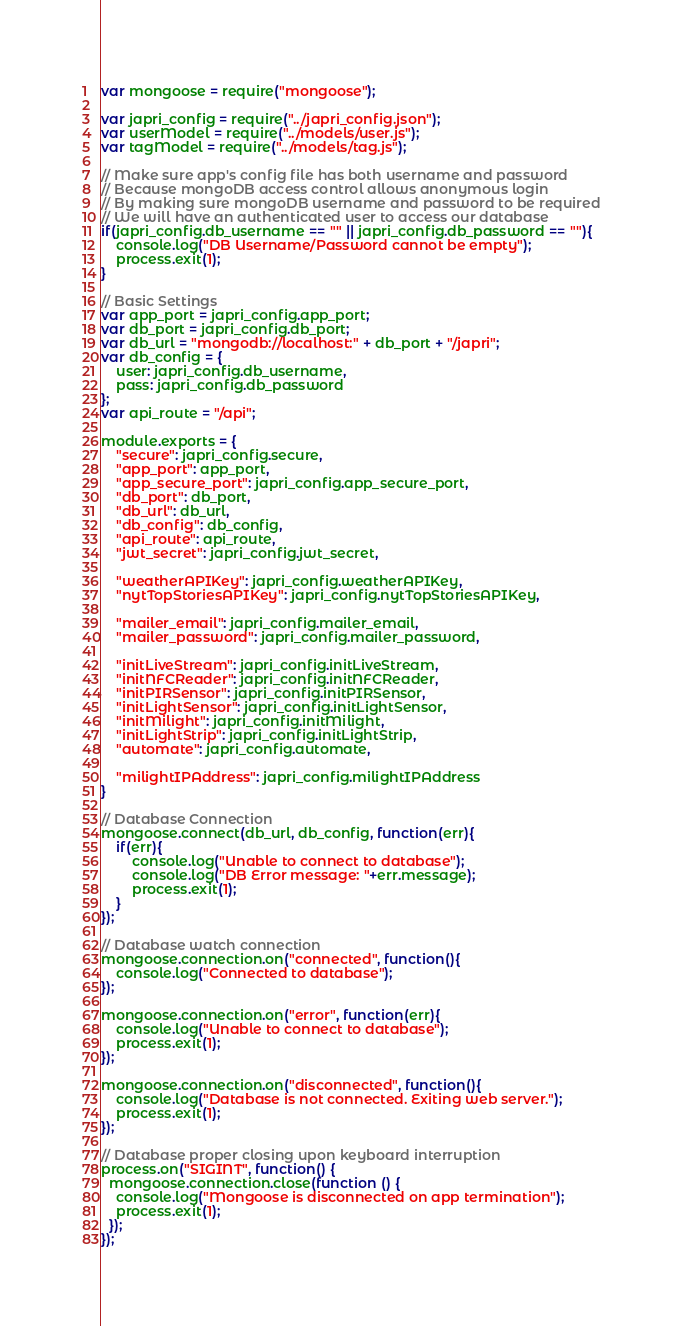Convert code to text. <code><loc_0><loc_0><loc_500><loc_500><_JavaScript_>var mongoose = require("mongoose");

var japri_config = require("../japri_config.json");
var userModel = require("../models/user.js");
var tagModel = require("../models/tag.js");

// Make sure app's config file has both username and password
// Because mongoDB access control allows anonymous login
// By making sure mongoDB username and password to be required
// We will have an authenticated user to access our database
if(japri_config.db_username == "" || japri_config.db_password == ""){
	console.log("DB Username/Password cannot be empty");
	process.exit(1);
}

// Basic Settings
var app_port = japri_config.app_port;
var db_port = japri_config.db_port;
var db_url = "mongodb://localhost:" + db_port + "/japri";
var db_config = {
	user: japri_config.db_username,
	pass: japri_config.db_password
};
var api_route = "/api";

module.exports = {
	"secure": japri_config.secure,
	"app_port": app_port,
	"app_secure_port": japri_config.app_secure_port,
	"db_port": db_port,
	"db_url": db_url,
	"db_config": db_config,
	"api_route": api_route,
	"jwt_secret": japri_config.jwt_secret,

	"weatherAPIKey": japri_config.weatherAPIKey,
    "nytTopStoriesAPIKey": japri_config.nytTopStoriesAPIKey,

    "mailer_email": japri_config.mailer_email,
    "mailer_password": japri_config.mailer_password,

	"initLiveStream": japri_config.initLiveStream,
	"initNFCReader": japri_config.initNFCReader,
	"initPIRSensor": japri_config.initPIRSensor,
	"initLightSensor": japri_config.initLightSensor,
	"initMilight": japri_config.initMilight,
	"initLightStrip": japri_config.initLightStrip,
	"automate": japri_config.automate,

	"milightIPAddress": japri_config.milightIPAddress
}

// Database Connection
mongoose.connect(db_url, db_config, function(err){
	if(err){
		console.log("Unable to connect to database");
		console.log("DB Error message: "+err.message);
		process.exit(1);	
	}
});

// Database watch connection
mongoose.connection.on("connected", function(){
	console.log("Connected to database");
});

mongoose.connection.on("error", function(err){
	console.log("Unable to connect to database");
	process.exit(1);
});

mongoose.connection.on("disconnected", function(){
	console.log("Database is not connected. Exiting web server.");
	process.exit(1);
});

// Database proper closing upon keyboard interruption
process.on("SIGINT", function() {
  mongoose.connection.close(function () {
    console.log("Mongoose is disconnected on app termination");
    process.exit(1);
  });
});
</code> 